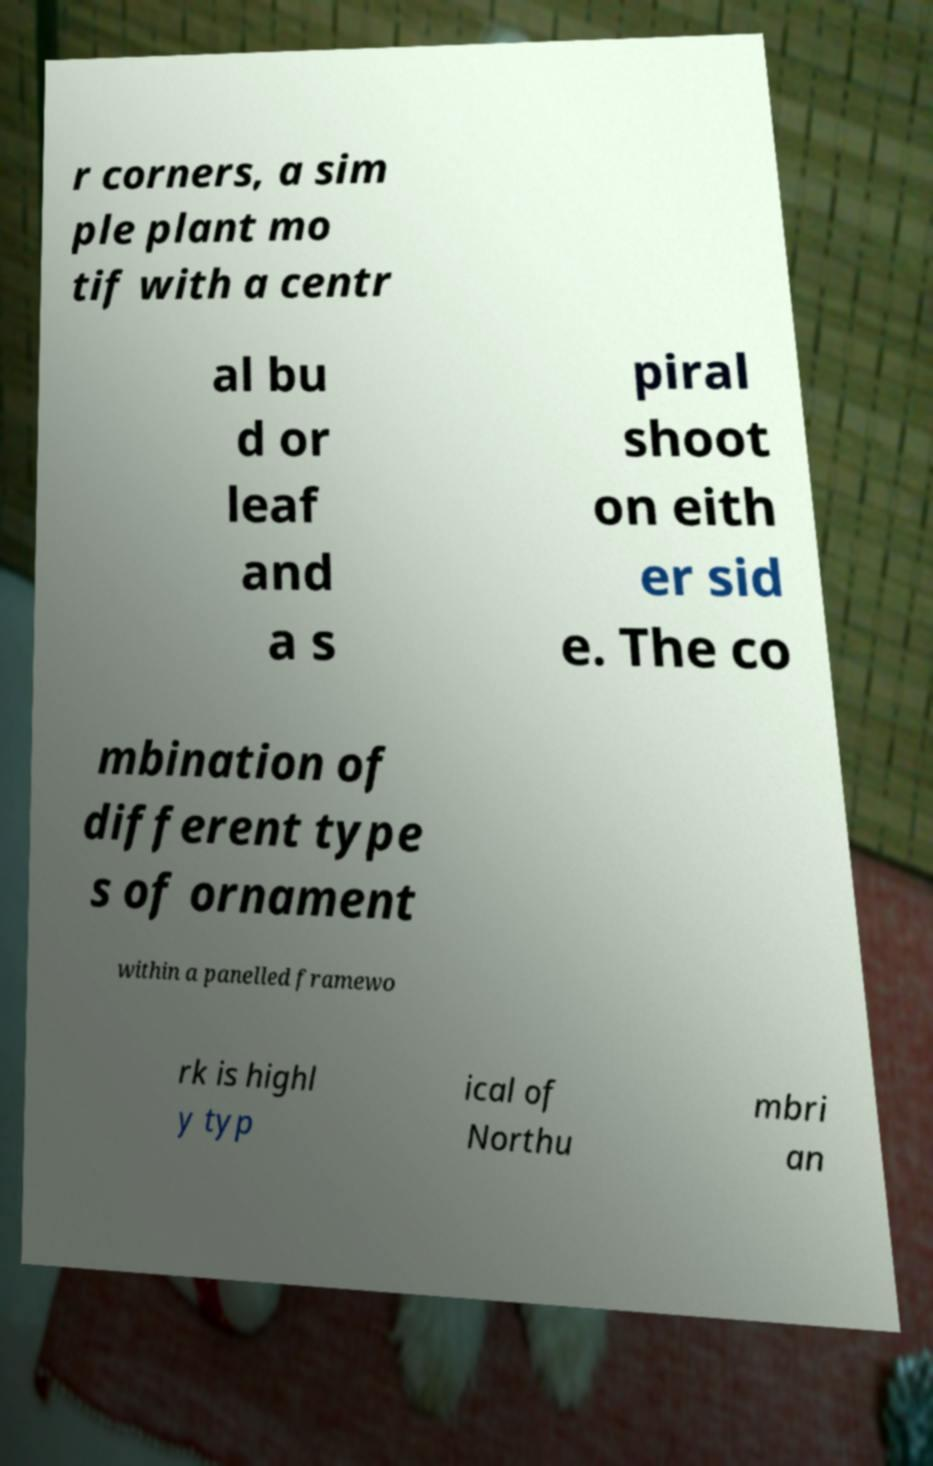Please read and relay the text visible in this image. What does it say? r corners, a sim ple plant mo tif with a centr al bu d or leaf and a s piral shoot on eith er sid e. The co mbination of different type s of ornament within a panelled framewo rk is highl y typ ical of Northu mbri an 